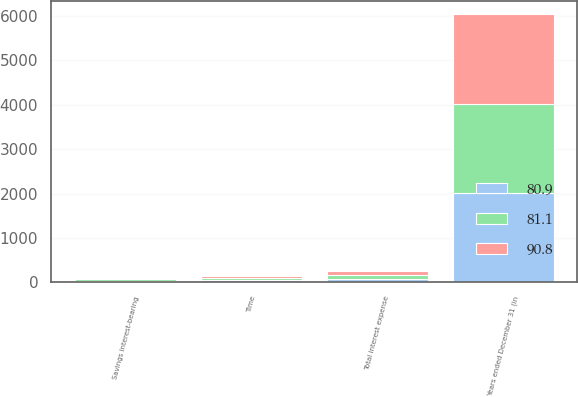Convert chart. <chart><loc_0><loc_0><loc_500><loc_500><stacked_bar_chart><ecel><fcel>Years ended December 31 (in<fcel>Savings interest-bearing<fcel>Time<fcel>Total interest expense<nl><fcel>80.9<fcel>2014<fcel>36.7<fcel>44.2<fcel>80.9<nl><fcel>90.8<fcel>2013<fcel>33<fcel>48.1<fcel>81.1<nl><fcel>81.1<fcel>2012<fcel>38.7<fcel>52.1<fcel>90.8<nl></chart> 